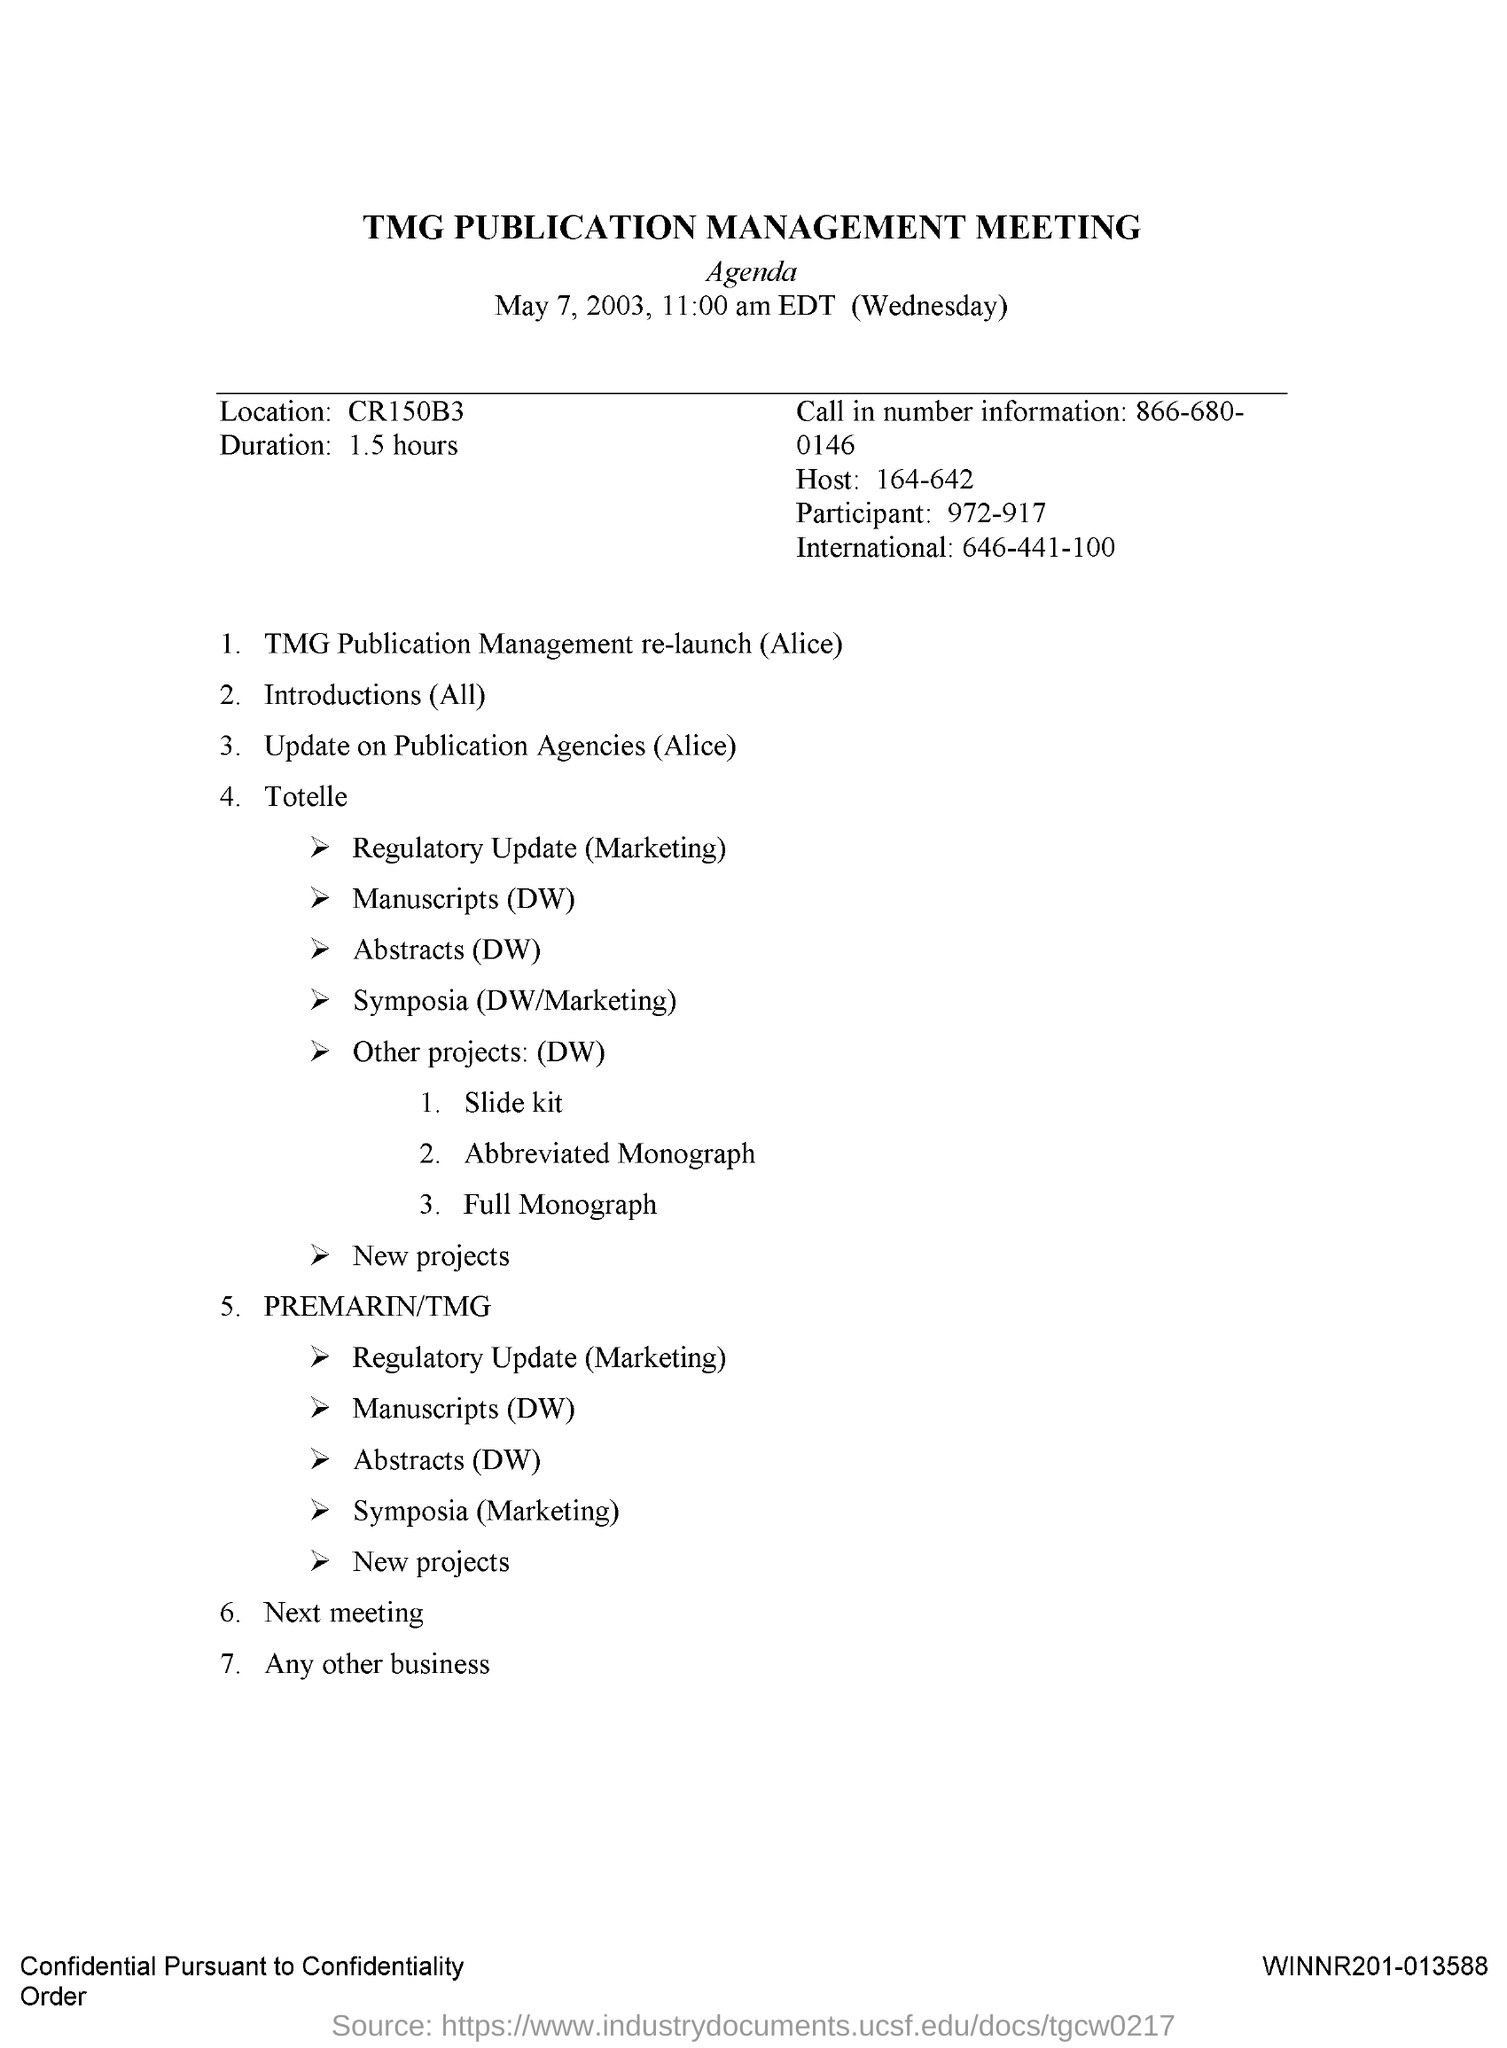Highlight a few significant elements in this photo. The call-in number is 866-680-0146. The TMG Publication Management Meeting was held on May 7, 2003. 